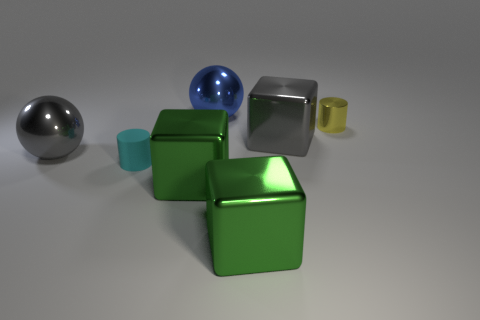Add 3 red spheres. How many objects exist? 10 Subtract all cubes. How many objects are left? 4 Add 5 big metallic cubes. How many big metallic cubes are left? 8 Add 7 blue metal balls. How many blue metal balls exist? 8 Subtract 0 red cubes. How many objects are left? 7 Subtract all large gray shiny spheres. Subtract all small gray rubber cubes. How many objects are left? 6 